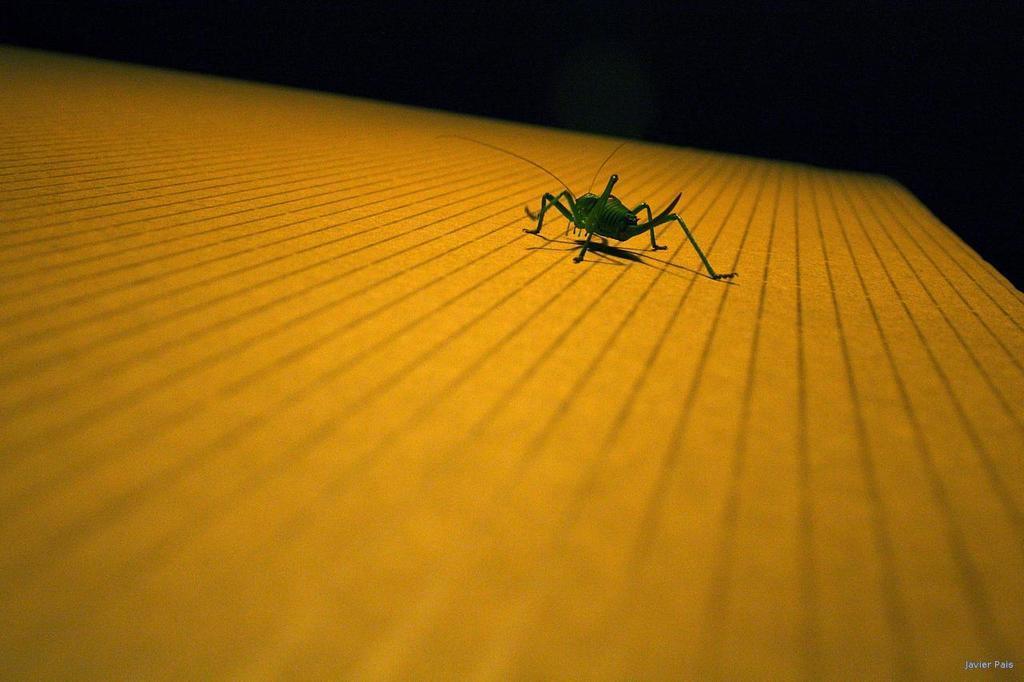In one or two sentences, can you explain what this image depicts? In this image I can see a green color insect on the yellow color surface. Background is in black color. 